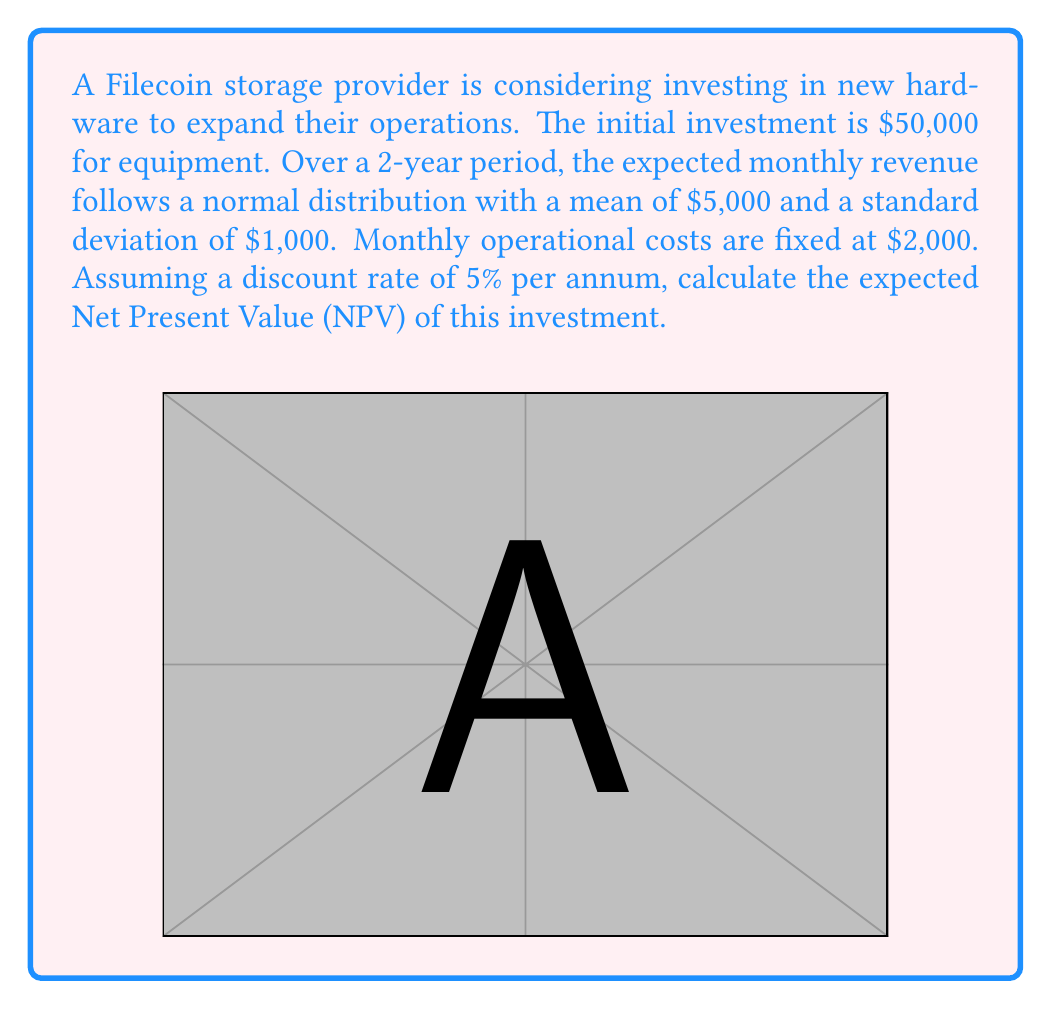Solve this math problem. Let's approach this step-by-step:

1) First, calculate the expected monthly profit:
   Expected Revenue: $5,000
   Fixed Costs: $2,000
   Expected Monthly Profit = $5,000 - $2,000 = $3,000

2) Calculate the monthly discount rate:
   Annual rate = 5% = 0.05
   Monthly rate = $(1 + 0.05)^{1/12} - 1 \approx 0.004074$

3) Calculate the present value of the expected profits over 24 months:
   $PV = \sum_{t=1}^{24} \frac{3000}{(1 + 0.004074)^t}$

4) This is a geometric series with:
   $a = \frac{3000}{1.004074} \approx 2987.83$
   $r = \frac{1}{1.004074} \approx 0.995944$
   $n = 24$

   Using the formula for the sum of a geometric series:
   $S_n = a\frac{1-r^n}{1-r}$

   $PV = 2987.83 \cdot \frac{1-0.995944^{24}}{1-0.995944} \approx 69,241.76$

5) Calculate the NPV:
   $NPV = -50,000 + 69,241.76 = 19,241.76$

Therefore, the expected NPV of the investment is approximately $19,241.76.
Answer: $19,241.76 